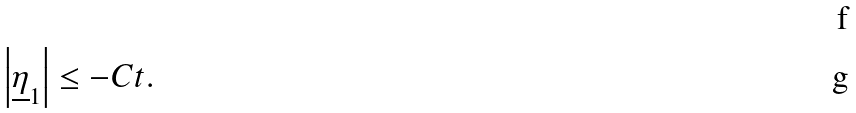Convert formula to latex. <formula><loc_0><loc_0><loc_500><loc_500>\\ \left | \underline { \eta } _ { 1 } \right | \leq - C t .</formula> 